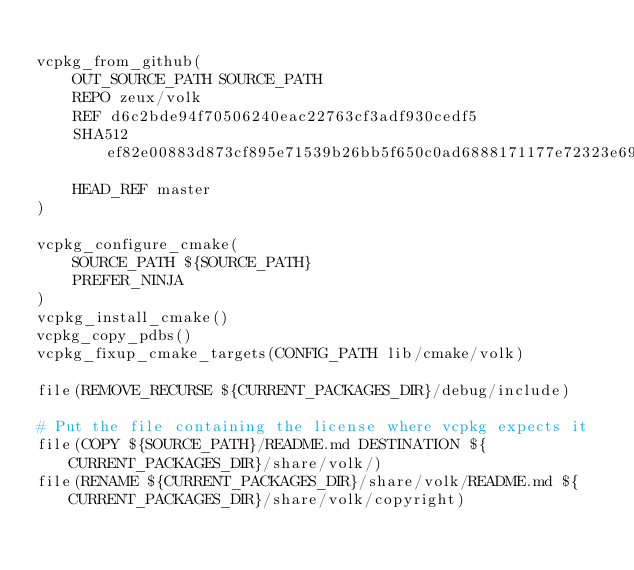<code> <loc_0><loc_0><loc_500><loc_500><_CMake_>
vcpkg_from_github(
    OUT_SOURCE_PATH SOURCE_PATH
    REPO zeux/volk
    REF d6c2bde94f70506240eac22763cf3adf930cedf5
    SHA512 ef82e00883d873cf895e71539b26bb5f650c0ad6888171177e72323e69a80d3b6767b73bae086b93f2bec144c1d95cc169b5bb8faf4ad0bca600a6ad623942dc
    HEAD_REF master
)

vcpkg_configure_cmake(
    SOURCE_PATH ${SOURCE_PATH}
    PREFER_NINJA
)
vcpkg_install_cmake()
vcpkg_copy_pdbs()
vcpkg_fixup_cmake_targets(CONFIG_PATH lib/cmake/volk)

file(REMOVE_RECURSE ${CURRENT_PACKAGES_DIR}/debug/include)

# Put the file containing the license where vcpkg expects it
file(COPY ${SOURCE_PATH}/README.md DESTINATION ${CURRENT_PACKAGES_DIR}/share/volk/)
file(RENAME ${CURRENT_PACKAGES_DIR}/share/volk/README.md ${CURRENT_PACKAGES_DIR}/share/volk/copyright)
</code> 